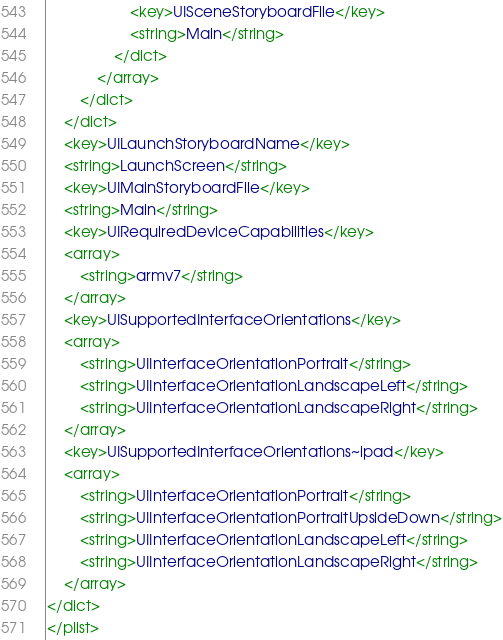<code> <loc_0><loc_0><loc_500><loc_500><_XML_>					<key>UISceneStoryboardFile</key>
					<string>Main</string>
				</dict>
			</array>
		</dict>
	</dict>
	<key>UILaunchStoryboardName</key>
	<string>LaunchScreen</string>
	<key>UIMainStoryboardFile</key>
	<string>Main</string>
	<key>UIRequiredDeviceCapabilities</key>
	<array>
		<string>armv7</string>
	</array>
	<key>UISupportedInterfaceOrientations</key>
	<array>
		<string>UIInterfaceOrientationPortrait</string>
		<string>UIInterfaceOrientationLandscapeLeft</string>
		<string>UIInterfaceOrientationLandscapeRight</string>
	</array>
	<key>UISupportedInterfaceOrientations~ipad</key>
	<array>
		<string>UIInterfaceOrientationPortrait</string>
		<string>UIInterfaceOrientationPortraitUpsideDown</string>
		<string>UIInterfaceOrientationLandscapeLeft</string>
		<string>UIInterfaceOrientationLandscapeRight</string>
	</array>
</dict>
</plist>
</code> 